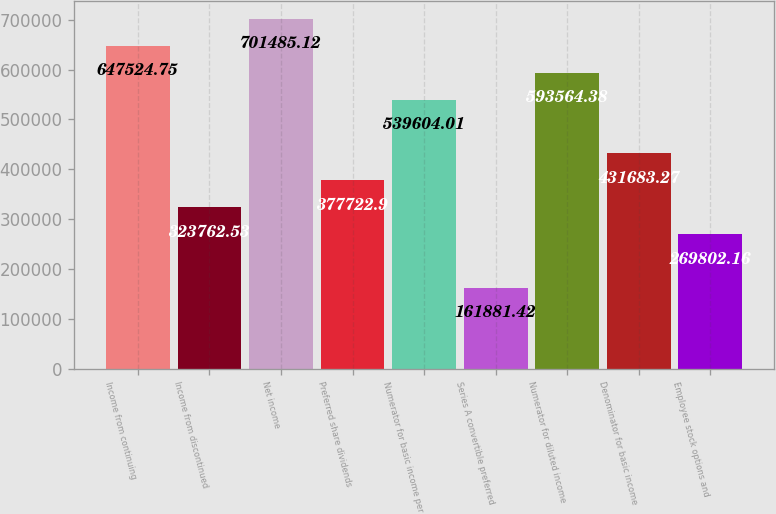<chart> <loc_0><loc_0><loc_500><loc_500><bar_chart><fcel>Income from continuing<fcel>Income from discontinued<fcel>Net income<fcel>Preferred share dividends<fcel>Numerator for basic income per<fcel>Series A convertible preferred<fcel>Numerator for diluted income<fcel>Denominator for basic income<fcel>Employee stock options and<nl><fcel>647525<fcel>323763<fcel>701485<fcel>377723<fcel>539604<fcel>161881<fcel>593564<fcel>431683<fcel>269802<nl></chart> 